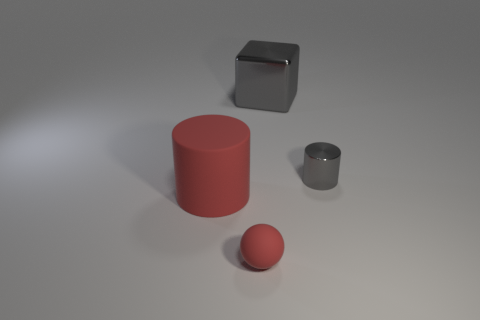What material is the cylinder that is the same color as the sphere?
Give a very brief answer. Rubber. What is the size of the gray shiny object that is right of the large gray block behind the matte thing that is left of the sphere?
Ensure brevity in your answer.  Small. Are there more big red rubber cylinders that are right of the cube than blocks behind the big matte object?
Offer a terse response. No. There is a object left of the rubber sphere; what number of big cylinders are right of it?
Your answer should be very brief. 0. Is there a thing that has the same color as the large cylinder?
Give a very brief answer. Yes. Do the red ball and the gray cube have the same size?
Offer a terse response. No. Does the large cube have the same color as the metal cylinder?
Your answer should be compact. Yes. What material is the gray object on the right side of the thing behind the tiny cylinder?
Provide a succinct answer. Metal. What is the material of the tiny thing that is the same shape as the large red thing?
Offer a very short reply. Metal. Do the matte object that is behind the rubber sphere and the small cylinder have the same size?
Provide a succinct answer. No. 